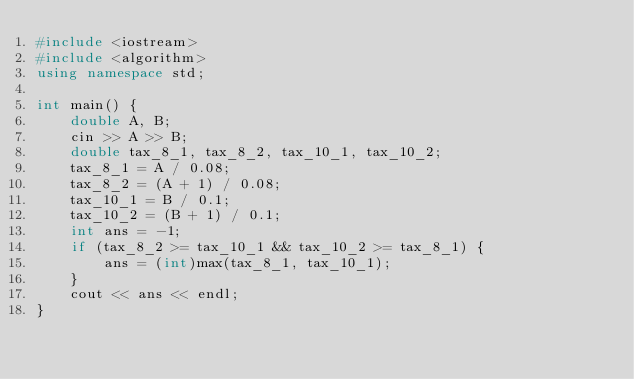<code> <loc_0><loc_0><loc_500><loc_500><_C++_>#include <iostream>
#include <algorithm>
using namespace std;

int main() {
	double A, B;
	cin >> A >> B;
	double tax_8_1, tax_8_2, tax_10_1, tax_10_2;
	tax_8_1 = A / 0.08;
	tax_8_2 = (A + 1) / 0.08;
	tax_10_1 = B / 0.1;
	tax_10_2 = (B + 1) / 0.1;
	int ans = -1;
	if (tax_8_2 >= tax_10_1 && tax_10_2 >= tax_8_1) {
		ans = (int)max(tax_8_1, tax_10_1);
	}
	cout << ans << endl;
}</code> 